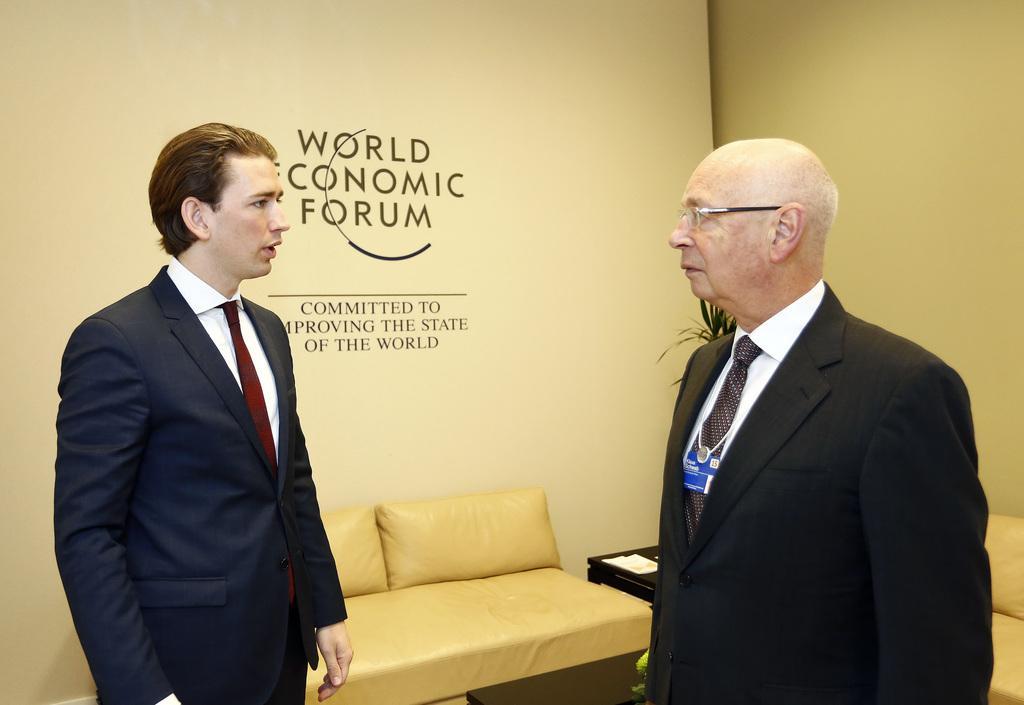Could you give a brief overview of what you see in this image? Here we can see 2 persons are standing on the floor, and in front here is the sofa, and here is the wall, and here is the tree. 